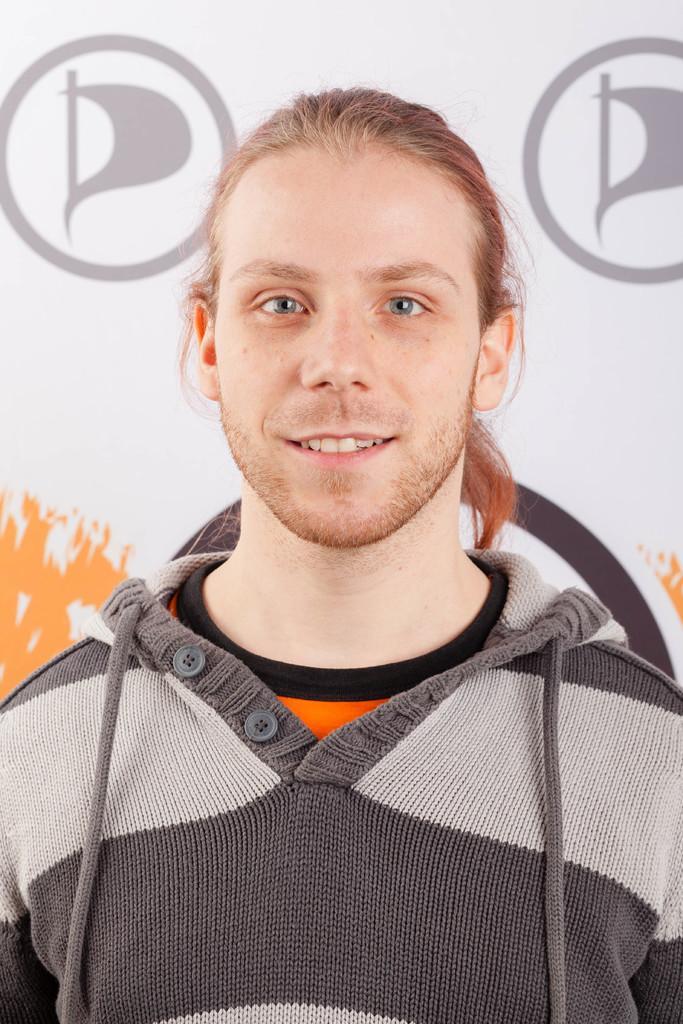Could you give a brief overview of what you see in this image? In this image I can see the person wearing the grey, orange, black and ash color. And there is a banner in the back. 